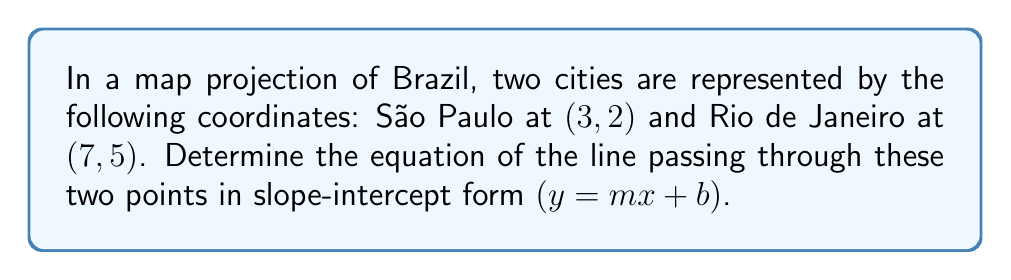Can you answer this question? To find the equation of the line passing through two points, we'll follow these steps:

1. Calculate the slope $(m)$ using the slope formula:
   $$m = \frac{y_2 - y_1}{x_2 - x_1} = \frac{5 - 2}{7 - 3} = \frac{3}{4}$$

2. Use the point-slope form of a line with one of the given points (let's use São Paulo $(3, 2)$):
   $$y - y_1 = m(x - x_1)$$
   $$y - 2 = \frac{3}{4}(x - 3)$$

3. Expand the equation:
   $$y - 2 = \frac{3}{4}x - \frac{9}{4}$$

4. Solve for $y$ to get the slope-intercept form:
   $$y = \frac{3}{4}x - \frac{9}{4} + 2$$
   $$y = \frac{3}{4}x - \frac{1}{4}$$

Therefore, the equation of the line passing through São Paulo and Rio de Janeiro in the map projection is $y = \frac{3}{4}x - \frac{1}{4}$.
Answer: $y = \frac{3}{4}x - \frac{1}{4}$ 